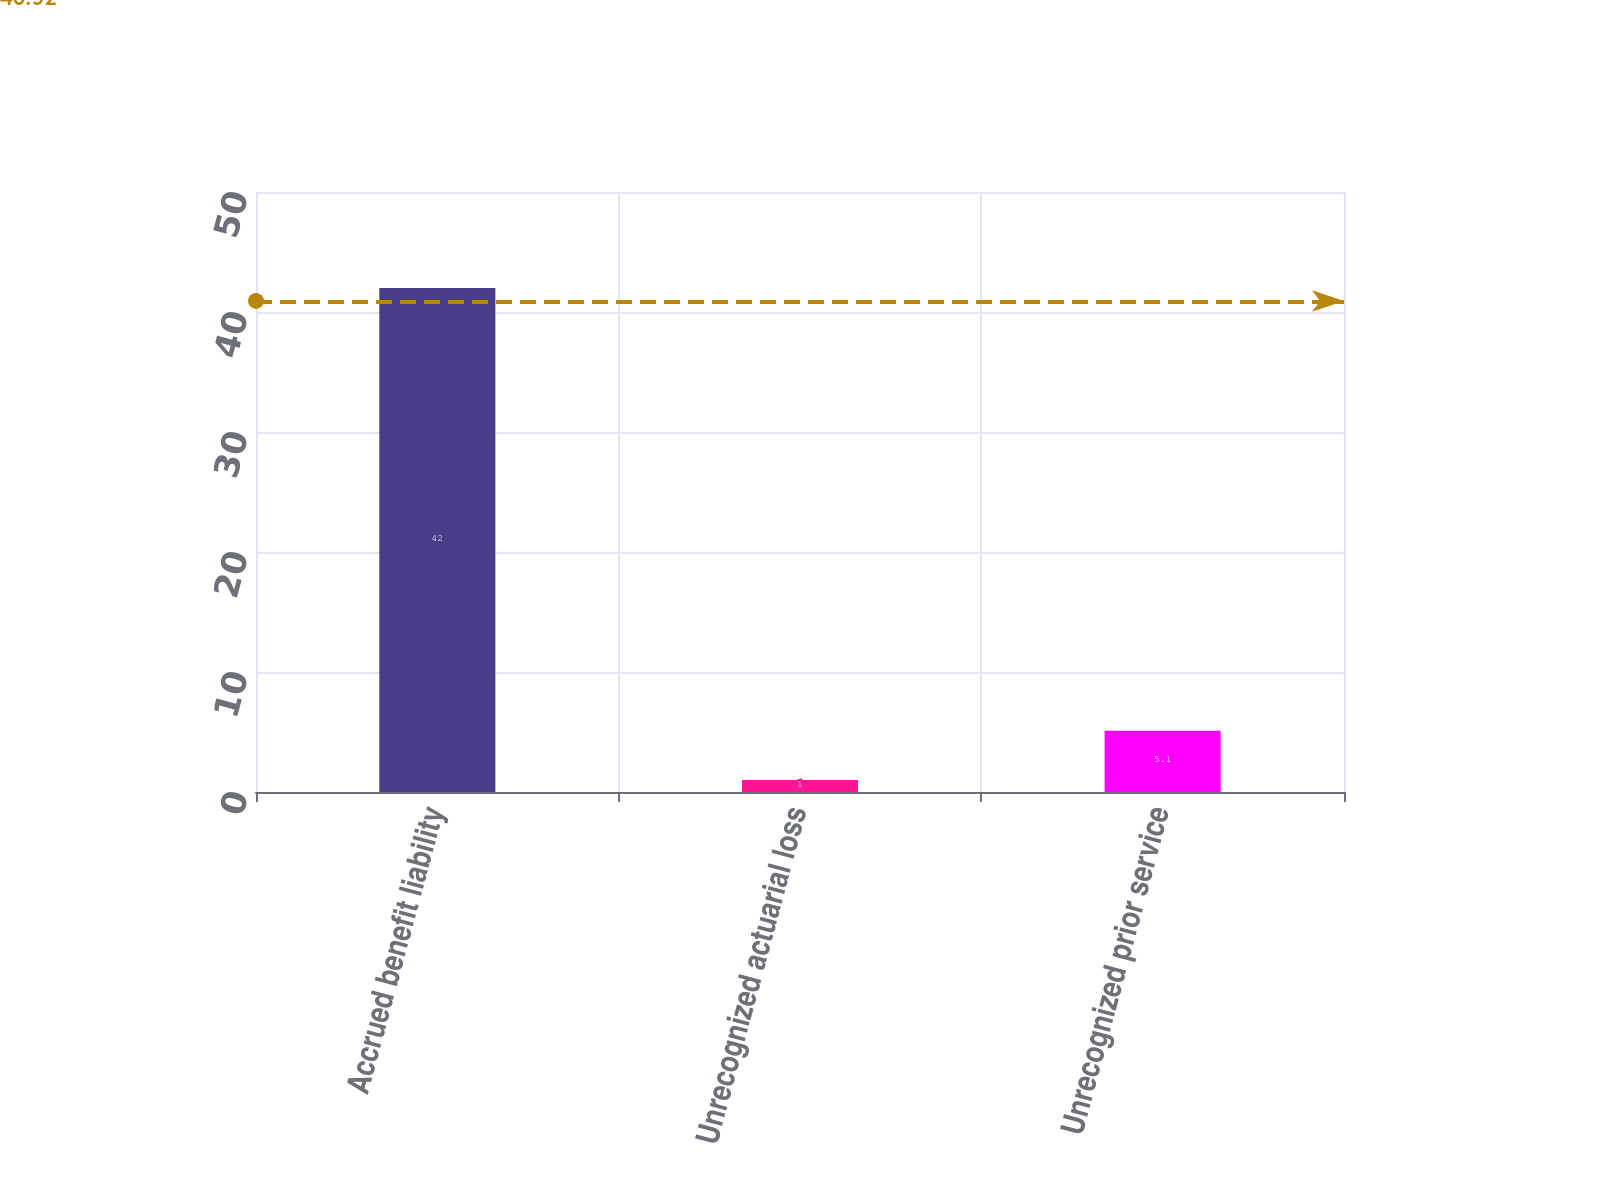<chart> <loc_0><loc_0><loc_500><loc_500><bar_chart><fcel>Accrued benefit liability<fcel>Unrecognized actuarial loss<fcel>Unrecognized prior service<nl><fcel>42<fcel>1<fcel>5.1<nl></chart> 